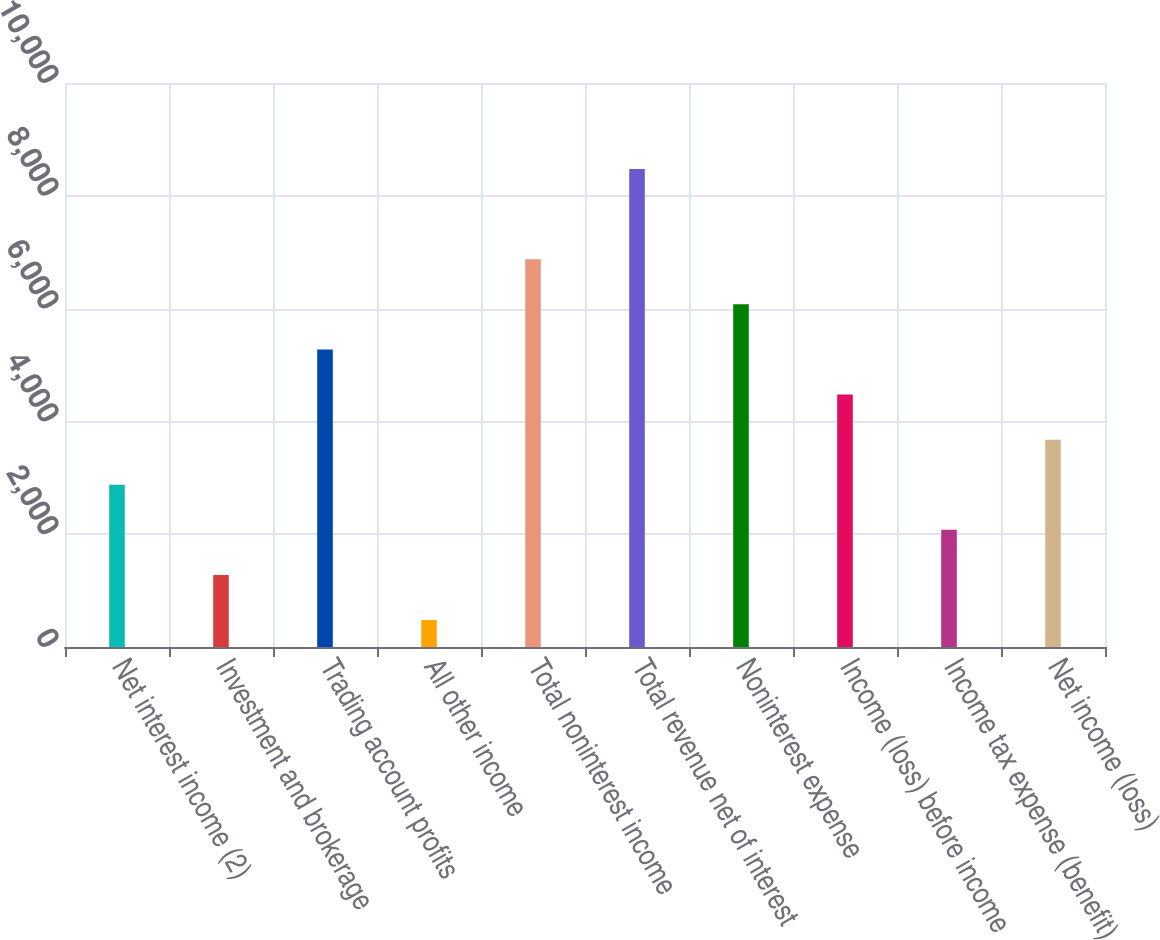<chart> <loc_0><loc_0><loc_500><loc_500><bar_chart><fcel>Net interest income (2)<fcel>Investment and brokerage<fcel>Trading account profits<fcel>All other income<fcel>Total noninterest income<fcel>Total revenue net of interest<fcel>Noninterest expense<fcel>Income (loss) before income<fcel>Income tax expense (benefit)<fcel>Net income (loss)<nl><fcel>2877.1<fcel>1277.7<fcel>5276.2<fcel>478<fcel>6875.6<fcel>8475<fcel>6075.9<fcel>4476.5<fcel>2077.4<fcel>3676.8<nl></chart> 